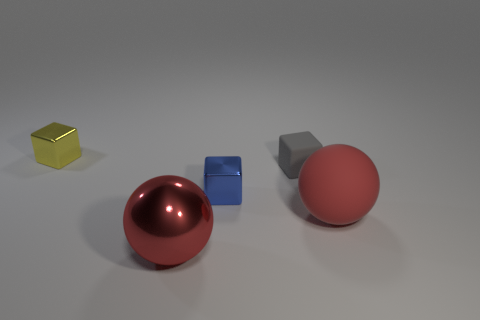Add 4 big red metallic cylinders. How many objects exist? 9 Subtract all balls. How many objects are left? 3 Add 4 gray matte things. How many gray matte things are left? 5 Add 1 red matte spheres. How many red matte spheres exist? 2 Subtract 0 purple blocks. How many objects are left? 5 Subtract all big gray matte cubes. Subtract all red objects. How many objects are left? 3 